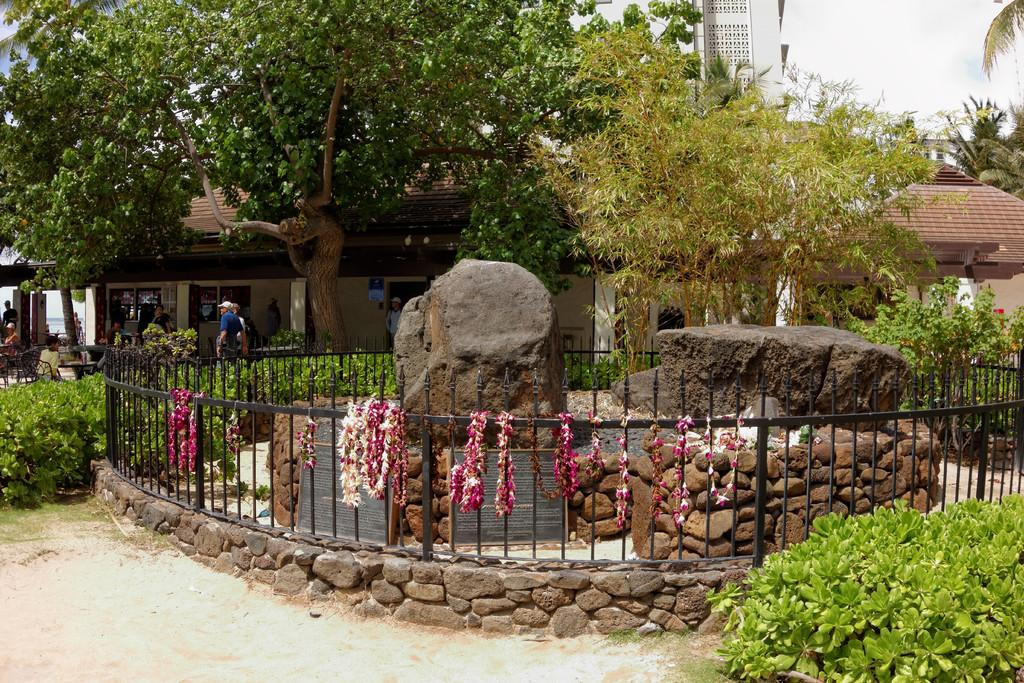What type of natural elements can be seen in the image? There are rocks, plants, and trees in the image. What man-made objects are present in the image? There are boards, iron grilles, and buildings in the image. What decorative items can be seen on the iron grilles? There are flower garlands on the iron grilles in the image. Are there any living beings in the image? Yes, there is a group of people in the image. What is visible in the background of the image? The sky is visible in the background of the image. Where is the playground located in the image? There is no playground present in the image. What type of industry can be seen in the image? There is no industry depicted in the image. 